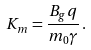Convert formula to latex. <formula><loc_0><loc_0><loc_500><loc_500>K _ { m } = \frac { B _ { g } q } { m _ { 0 } \gamma } \, .</formula> 